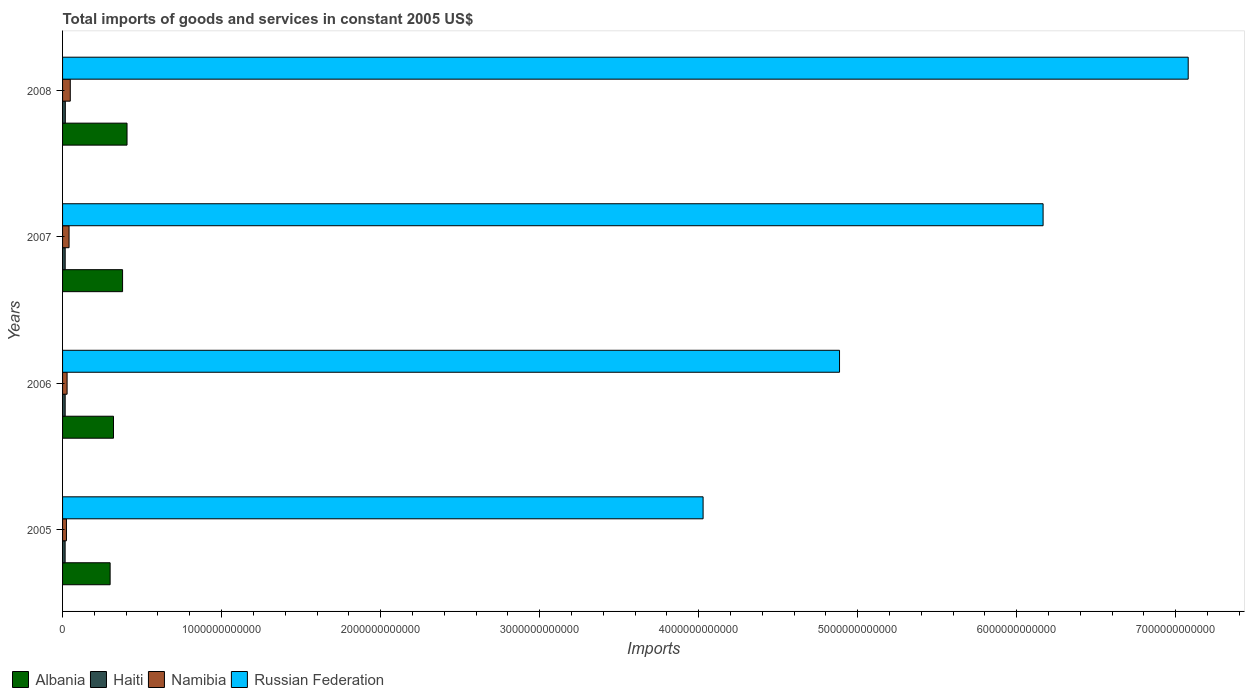How many groups of bars are there?
Your answer should be very brief. 4. Are the number of bars on each tick of the Y-axis equal?
Keep it short and to the point. Yes. How many bars are there on the 2nd tick from the bottom?
Make the answer very short. 4. In how many cases, is the number of bars for a given year not equal to the number of legend labels?
Your answer should be compact. 0. What is the total imports of goods and services in Albania in 2007?
Offer a terse response. 3.77e+11. Across all years, what is the maximum total imports of goods and services in Albania?
Offer a terse response. 4.05e+11. Across all years, what is the minimum total imports of goods and services in Russian Federation?
Give a very brief answer. 4.03e+12. In which year was the total imports of goods and services in Albania minimum?
Your answer should be compact. 2005. What is the total total imports of goods and services in Albania in the graph?
Provide a short and direct response. 1.40e+12. What is the difference between the total imports of goods and services in Albania in 2005 and that in 2008?
Your response must be concise. -1.06e+11. What is the difference between the total imports of goods and services in Namibia in 2005 and the total imports of goods and services in Albania in 2008?
Your answer should be compact. -3.81e+11. What is the average total imports of goods and services in Albania per year?
Your response must be concise. 3.51e+11. In the year 2005, what is the difference between the total imports of goods and services in Albania and total imports of goods and services in Namibia?
Make the answer very short. 2.75e+11. In how many years, is the total imports of goods and services in Albania greater than 2600000000000 US$?
Keep it short and to the point. 0. What is the ratio of the total imports of goods and services in Albania in 2005 to that in 2008?
Keep it short and to the point. 0.74. Is the total imports of goods and services in Albania in 2006 less than that in 2007?
Make the answer very short. Yes. Is the difference between the total imports of goods and services in Albania in 2005 and 2007 greater than the difference between the total imports of goods and services in Namibia in 2005 and 2007?
Offer a terse response. No. What is the difference between the highest and the second highest total imports of goods and services in Namibia?
Provide a short and direct response. 7.63e+09. What is the difference between the highest and the lowest total imports of goods and services in Russian Federation?
Offer a terse response. 3.05e+12. In how many years, is the total imports of goods and services in Albania greater than the average total imports of goods and services in Albania taken over all years?
Your answer should be very brief. 2. Is it the case that in every year, the sum of the total imports of goods and services in Haiti and total imports of goods and services in Russian Federation is greater than the sum of total imports of goods and services in Albania and total imports of goods and services in Namibia?
Provide a short and direct response. Yes. What does the 4th bar from the top in 2006 represents?
Provide a short and direct response. Albania. What does the 3rd bar from the bottom in 2005 represents?
Keep it short and to the point. Namibia. How many bars are there?
Offer a very short reply. 16. Are all the bars in the graph horizontal?
Make the answer very short. Yes. What is the difference between two consecutive major ticks on the X-axis?
Give a very brief answer. 1.00e+12. Are the values on the major ticks of X-axis written in scientific E-notation?
Make the answer very short. No. How many legend labels are there?
Your response must be concise. 4. What is the title of the graph?
Your answer should be very brief. Total imports of goods and services in constant 2005 US$. Does "Switzerland" appear as one of the legend labels in the graph?
Your answer should be compact. No. What is the label or title of the X-axis?
Ensure brevity in your answer.  Imports. What is the label or title of the Y-axis?
Offer a terse response. Years. What is the Imports in Albania in 2005?
Make the answer very short. 2.99e+11. What is the Imports of Haiti in 2005?
Your answer should be compact. 1.61e+1. What is the Imports of Namibia in 2005?
Your answer should be compact. 2.45e+1. What is the Imports in Russian Federation in 2005?
Provide a succinct answer. 4.03e+12. What is the Imports of Albania in 2006?
Your answer should be very brief. 3.20e+11. What is the Imports of Haiti in 2006?
Keep it short and to the point. 1.64e+1. What is the Imports of Namibia in 2006?
Offer a very short reply. 2.85e+1. What is the Imports of Russian Federation in 2006?
Make the answer very short. 4.89e+12. What is the Imports of Albania in 2007?
Your answer should be very brief. 3.77e+11. What is the Imports in Haiti in 2007?
Your answer should be very brief. 1.64e+1. What is the Imports of Namibia in 2007?
Your response must be concise. 4.09e+1. What is the Imports of Russian Federation in 2007?
Ensure brevity in your answer.  6.17e+12. What is the Imports in Albania in 2008?
Keep it short and to the point. 4.05e+11. What is the Imports in Haiti in 2008?
Offer a very short reply. 1.73e+1. What is the Imports of Namibia in 2008?
Offer a terse response. 4.85e+1. What is the Imports in Russian Federation in 2008?
Provide a succinct answer. 7.08e+12. Across all years, what is the maximum Imports in Albania?
Offer a very short reply. 4.05e+11. Across all years, what is the maximum Imports in Haiti?
Provide a short and direct response. 1.73e+1. Across all years, what is the maximum Imports in Namibia?
Provide a succinct answer. 4.85e+1. Across all years, what is the maximum Imports of Russian Federation?
Offer a very short reply. 7.08e+12. Across all years, what is the minimum Imports in Albania?
Your answer should be very brief. 2.99e+11. Across all years, what is the minimum Imports in Haiti?
Ensure brevity in your answer.  1.61e+1. Across all years, what is the minimum Imports in Namibia?
Give a very brief answer. 2.45e+1. Across all years, what is the minimum Imports in Russian Federation?
Give a very brief answer. 4.03e+12. What is the total Imports in Albania in the graph?
Offer a very short reply. 1.40e+12. What is the total Imports in Haiti in the graph?
Ensure brevity in your answer.  6.62e+1. What is the total Imports in Namibia in the graph?
Make the answer very short. 1.42e+11. What is the total Imports of Russian Federation in the graph?
Provide a succinct answer. 2.22e+13. What is the difference between the Imports in Albania in 2005 and that in 2006?
Keep it short and to the point. -2.12e+1. What is the difference between the Imports in Haiti in 2005 and that in 2006?
Make the answer very short. -3.03e+08. What is the difference between the Imports in Namibia in 2005 and that in 2006?
Give a very brief answer. -3.99e+09. What is the difference between the Imports in Russian Federation in 2005 and that in 2006?
Give a very brief answer. -8.58e+11. What is the difference between the Imports in Albania in 2005 and that in 2007?
Provide a succinct answer. -7.83e+1. What is the difference between the Imports of Haiti in 2005 and that in 2007?
Provide a succinct answer. -3.78e+08. What is the difference between the Imports in Namibia in 2005 and that in 2007?
Keep it short and to the point. -1.64e+1. What is the difference between the Imports in Russian Federation in 2005 and that in 2007?
Offer a terse response. -2.14e+12. What is the difference between the Imports of Albania in 2005 and that in 2008?
Offer a terse response. -1.06e+11. What is the difference between the Imports of Haiti in 2005 and that in 2008?
Your answer should be compact. -1.24e+09. What is the difference between the Imports of Namibia in 2005 and that in 2008?
Make the answer very short. -2.40e+1. What is the difference between the Imports in Russian Federation in 2005 and that in 2008?
Offer a terse response. -3.05e+12. What is the difference between the Imports in Albania in 2006 and that in 2007?
Ensure brevity in your answer.  -5.71e+1. What is the difference between the Imports in Haiti in 2006 and that in 2007?
Your response must be concise. -7.50e+07. What is the difference between the Imports of Namibia in 2006 and that in 2007?
Keep it short and to the point. -1.24e+1. What is the difference between the Imports of Russian Federation in 2006 and that in 2007?
Make the answer very short. -1.28e+12. What is the difference between the Imports of Albania in 2006 and that in 2008?
Your answer should be very brief. -8.51e+1. What is the difference between the Imports in Haiti in 2006 and that in 2008?
Give a very brief answer. -9.42e+08. What is the difference between the Imports in Namibia in 2006 and that in 2008?
Provide a succinct answer. -2.00e+1. What is the difference between the Imports of Russian Federation in 2006 and that in 2008?
Make the answer very short. -2.19e+12. What is the difference between the Imports of Albania in 2007 and that in 2008?
Give a very brief answer. -2.80e+1. What is the difference between the Imports of Haiti in 2007 and that in 2008?
Provide a succinct answer. -8.67e+08. What is the difference between the Imports of Namibia in 2007 and that in 2008?
Make the answer very short. -7.63e+09. What is the difference between the Imports of Russian Federation in 2007 and that in 2008?
Your answer should be very brief. -9.13e+11. What is the difference between the Imports in Albania in 2005 and the Imports in Haiti in 2006?
Your response must be concise. 2.83e+11. What is the difference between the Imports of Albania in 2005 and the Imports of Namibia in 2006?
Make the answer very short. 2.71e+11. What is the difference between the Imports of Albania in 2005 and the Imports of Russian Federation in 2006?
Keep it short and to the point. -4.59e+12. What is the difference between the Imports in Haiti in 2005 and the Imports in Namibia in 2006?
Ensure brevity in your answer.  -1.24e+1. What is the difference between the Imports in Haiti in 2005 and the Imports in Russian Federation in 2006?
Provide a succinct answer. -4.87e+12. What is the difference between the Imports of Namibia in 2005 and the Imports of Russian Federation in 2006?
Your answer should be very brief. -4.86e+12. What is the difference between the Imports of Albania in 2005 and the Imports of Haiti in 2007?
Offer a very short reply. 2.83e+11. What is the difference between the Imports of Albania in 2005 and the Imports of Namibia in 2007?
Provide a succinct answer. 2.58e+11. What is the difference between the Imports of Albania in 2005 and the Imports of Russian Federation in 2007?
Offer a terse response. -5.87e+12. What is the difference between the Imports of Haiti in 2005 and the Imports of Namibia in 2007?
Your answer should be very brief. -2.48e+1. What is the difference between the Imports in Haiti in 2005 and the Imports in Russian Federation in 2007?
Give a very brief answer. -6.15e+12. What is the difference between the Imports in Namibia in 2005 and the Imports in Russian Federation in 2007?
Ensure brevity in your answer.  -6.14e+12. What is the difference between the Imports of Albania in 2005 and the Imports of Haiti in 2008?
Provide a short and direct response. 2.82e+11. What is the difference between the Imports of Albania in 2005 and the Imports of Namibia in 2008?
Your answer should be very brief. 2.51e+11. What is the difference between the Imports in Albania in 2005 and the Imports in Russian Federation in 2008?
Provide a short and direct response. -6.78e+12. What is the difference between the Imports of Haiti in 2005 and the Imports of Namibia in 2008?
Offer a very short reply. -3.24e+1. What is the difference between the Imports in Haiti in 2005 and the Imports in Russian Federation in 2008?
Your answer should be compact. -7.06e+12. What is the difference between the Imports of Namibia in 2005 and the Imports of Russian Federation in 2008?
Offer a terse response. -7.05e+12. What is the difference between the Imports in Albania in 2006 and the Imports in Haiti in 2007?
Offer a very short reply. 3.04e+11. What is the difference between the Imports of Albania in 2006 and the Imports of Namibia in 2007?
Provide a short and direct response. 2.79e+11. What is the difference between the Imports in Albania in 2006 and the Imports in Russian Federation in 2007?
Offer a very short reply. -5.85e+12. What is the difference between the Imports in Haiti in 2006 and the Imports in Namibia in 2007?
Your response must be concise. -2.45e+1. What is the difference between the Imports in Haiti in 2006 and the Imports in Russian Federation in 2007?
Provide a short and direct response. -6.15e+12. What is the difference between the Imports in Namibia in 2006 and the Imports in Russian Federation in 2007?
Ensure brevity in your answer.  -6.14e+12. What is the difference between the Imports of Albania in 2006 and the Imports of Haiti in 2008?
Keep it short and to the point. 3.03e+11. What is the difference between the Imports in Albania in 2006 and the Imports in Namibia in 2008?
Give a very brief answer. 2.72e+11. What is the difference between the Imports in Albania in 2006 and the Imports in Russian Federation in 2008?
Ensure brevity in your answer.  -6.76e+12. What is the difference between the Imports of Haiti in 2006 and the Imports of Namibia in 2008?
Make the answer very short. -3.21e+1. What is the difference between the Imports in Haiti in 2006 and the Imports in Russian Federation in 2008?
Make the answer very short. -7.06e+12. What is the difference between the Imports in Namibia in 2006 and the Imports in Russian Federation in 2008?
Give a very brief answer. -7.05e+12. What is the difference between the Imports in Albania in 2007 and the Imports in Haiti in 2008?
Offer a very short reply. 3.60e+11. What is the difference between the Imports in Albania in 2007 and the Imports in Namibia in 2008?
Make the answer very short. 3.29e+11. What is the difference between the Imports of Albania in 2007 and the Imports of Russian Federation in 2008?
Your response must be concise. -6.70e+12. What is the difference between the Imports of Haiti in 2007 and the Imports of Namibia in 2008?
Your answer should be compact. -3.21e+1. What is the difference between the Imports in Haiti in 2007 and the Imports in Russian Federation in 2008?
Keep it short and to the point. -7.06e+12. What is the difference between the Imports of Namibia in 2007 and the Imports of Russian Federation in 2008?
Give a very brief answer. -7.04e+12. What is the average Imports in Albania per year?
Your answer should be compact. 3.51e+11. What is the average Imports in Haiti per year?
Your answer should be compact. 1.65e+1. What is the average Imports of Namibia per year?
Offer a terse response. 3.56e+1. What is the average Imports of Russian Federation per year?
Your answer should be very brief. 5.54e+12. In the year 2005, what is the difference between the Imports in Albania and Imports in Haiti?
Ensure brevity in your answer.  2.83e+11. In the year 2005, what is the difference between the Imports in Albania and Imports in Namibia?
Your answer should be compact. 2.75e+11. In the year 2005, what is the difference between the Imports in Albania and Imports in Russian Federation?
Your response must be concise. -3.73e+12. In the year 2005, what is the difference between the Imports in Haiti and Imports in Namibia?
Offer a terse response. -8.40e+09. In the year 2005, what is the difference between the Imports of Haiti and Imports of Russian Federation?
Give a very brief answer. -4.01e+12. In the year 2005, what is the difference between the Imports of Namibia and Imports of Russian Federation?
Provide a succinct answer. -4.00e+12. In the year 2006, what is the difference between the Imports of Albania and Imports of Haiti?
Your response must be concise. 3.04e+11. In the year 2006, what is the difference between the Imports of Albania and Imports of Namibia?
Make the answer very short. 2.92e+11. In the year 2006, what is the difference between the Imports in Albania and Imports in Russian Federation?
Give a very brief answer. -4.57e+12. In the year 2006, what is the difference between the Imports in Haiti and Imports in Namibia?
Your answer should be compact. -1.21e+1. In the year 2006, what is the difference between the Imports in Haiti and Imports in Russian Federation?
Provide a succinct answer. -4.87e+12. In the year 2006, what is the difference between the Imports of Namibia and Imports of Russian Federation?
Your answer should be very brief. -4.86e+12. In the year 2007, what is the difference between the Imports of Albania and Imports of Haiti?
Your response must be concise. 3.61e+11. In the year 2007, what is the difference between the Imports of Albania and Imports of Namibia?
Ensure brevity in your answer.  3.37e+11. In the year 2007, what is the difference between the Imports in Albania and Imports in Russian Federation?
Keep it short and to the point. -5.79e+12. In the year 2007, what is the difference between the Imports in Haiti and Imports in Namibia?
Make the answer very short. -2.44e+1. In the year 2007, what is the difference between the Imports in Haiti and Imports in Russian Federation?
Ensure brevity in your answer.  -6.15e+12. In the year 2007, what is the difference between the Imports of Namibia and Imports of Russian Federation?
Keep it short and to the point. -6.12e+12. In the year 2008, what is the difference between the Imports in Albania and Imports in Haiti?
Keep it short and to the point. 3.88e+11. In the year 2008, what is the difference between the Imports in Albania and Imports in Namibia?
Ensure brevity in your answer.  3.57e+11. In the year 2008, what is the difference between the Imports of Albania and Imports of Russian Federation?
Your answer should be very brief. -6.67e+12. In the year 2008, what is the difference between the Imports in Haiti and Imports in Namibia?
Offer a very short reply. -3.12e+1. In the year 2008, what is the difference between the Imports of Haiti and Imports of Russian Federation?
Your answer should be compact. -7.06e+12. In the year 2008, what is the difference between the Imports in Namibia and Imports in Russian Federation?
Make the answer very short. -7.03e+12. What is the ratio of the Imports in Albania in 2005 to that in 2006?
Your answer should be very brief. 0.93. What is the ratio of the Imports in Haiti in 2005 to that in 2006?
Ensure brevity in your answer.  0.98. What is the ratio of the Imports in Namibia in 2005 to that in 2006?
Give a very brief answer. 0.86. What is the ratio of the Imports in Russian Federation in 2005 to that in 2006?
Your response must be concise. 0.82. What is the ratio of the Imports of Albania in 2005 to that in 2007?
Offer a terse response. 0.79. What is the ratio of the Imports in Namibia in 2005 to that in 2007?
Provide a short and direct response. 0.6. What is the ratio of the Imports of Russian Federation in 2005 to that in 2007?
Your answer should be compact. 0.65. What is the ratio of the Imports of Albania in 2005 to that in 2008?
Make the answer very short. 0.74. What is the ratio of the Imports in Haiti in 2005 to that in 2008?
Provide a short and direct response. 0.93. What is the ratio of the Imports of Namibia in 2005 to that in 2008?
Provide a short and direct response. 0.5. What is the ratio of the Imports of Russian Federation in 2005 to that in 2008?
Offer a very short reply. 0.57. What is the ratio of the Imports in Albania in 2006 to that in 2007?
Give a very brief answer. 0.85. What is the ratio of the Imports in Namibia in 2006 to that in 2007?
Provide a succinct answer. 0.7. What is the ratio of the Imports in Russian Federation in 2006 to that in 2007?
Ensure brevity in your answer.  0.79. What is the ratio of the Imports in Albania in 2006 to that in 2008?
Give a very brief answer. 0.79. What is the ratio of the Imports of Haiti in 2006 to that in 2008?
Give a very brief answer. 0.95. What is the ratio of the Imports of Namibia in 2006 to that in 2008?
Ensure brevity in your answer.  0.59. What is the ratio of the Imports in Russian Federation in 2006 to that in 2008?
Keep it short and to the point. 0.69. What is the ratio of the Imports in Albania in 2007 to that in 2008?
Offer a very short reply. 0.93. What is the ratio of the Imports of Haiti in 2007 to that in 2008?
Offer a very short reply. 0.95. What is the ratio of the Imports in Namibia in 2007 to that in 2008?
Provide a succinct answer. 0.84. What is the ratio of the Imports of Russian Federation in 2007 to that in 2008?
Provide a short and direct response. 0.87. What is the difference between the highest and the second highest Imports of Albania?
Offer a terse response. 2.80e+1. What is the difference between the highest and the second highest Imports of Haiti?
Keep it short and to the point. 8.67e+08. What is the difference between the highest and the second highest Imports of Namibia?
Provide a succinct answer. 7.63e+09. What is the difference between the highest and the second highest Imports of Russian Federation?
Provide a succinct answer. 9.13e+11. What is the difference between the highest and the lowest Imports of Albania?
Keep it short and to the point. 1.06e+11. What is the difference between the highest and the lowest Imports of Haiti?
Make the answer very short. 1.24e+09. What is the difference between the highest and the lowest Imports in Namibia?
Keep it short and to the point. 2.40e+1. What is the difference between the highest and the lowest Imports of Russian Federation?
Offer a terse response. 3.05e+12. 